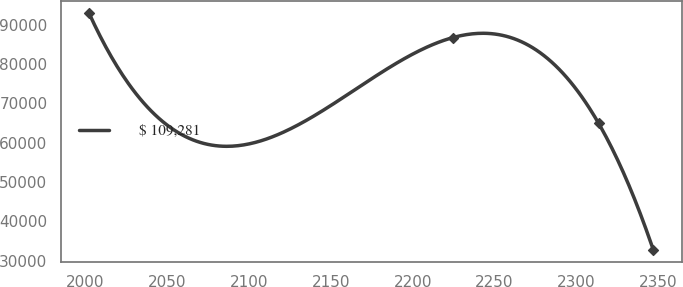Convert chart to OTSL. <chart><loc_0><loc_0><loc_500><loc_500><line_chart><ecel><fcel>$ 109,281<nl><fcel>2002.37<fcel>93016.4<nl><fcel>2224.61<fcel>86705.8<nl><fcel>2313.48<fcel>64907.7<nl><fcel>2346.93<fcel>32653<nl></chart> 